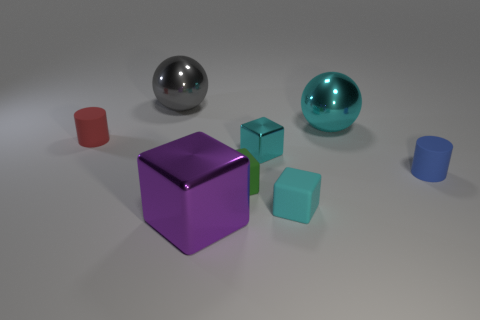Add 1 large blocks. How many objects exist? 9 Subtract all green blocks. How many blocks are left? 3 Subtract all cylinders. How many objects are left? 6 Subtract all gray cylinders. Subtract all green cubes. How many cylinders are left? 2 Subtract all cyan balls. How many cyan cylinders are left? 0 Subtract all tiny cubes. Subtract all tiny green matte things. How many objects are left? 4 Add 8 big spheres. How many big spheres are left? 10 Add 2 small matte objects. How many small matte objects exist? 6 Subtract all green cubes. How many cubes are left? 3 Subtract 1 purple cubes. How many objects are left? 7 